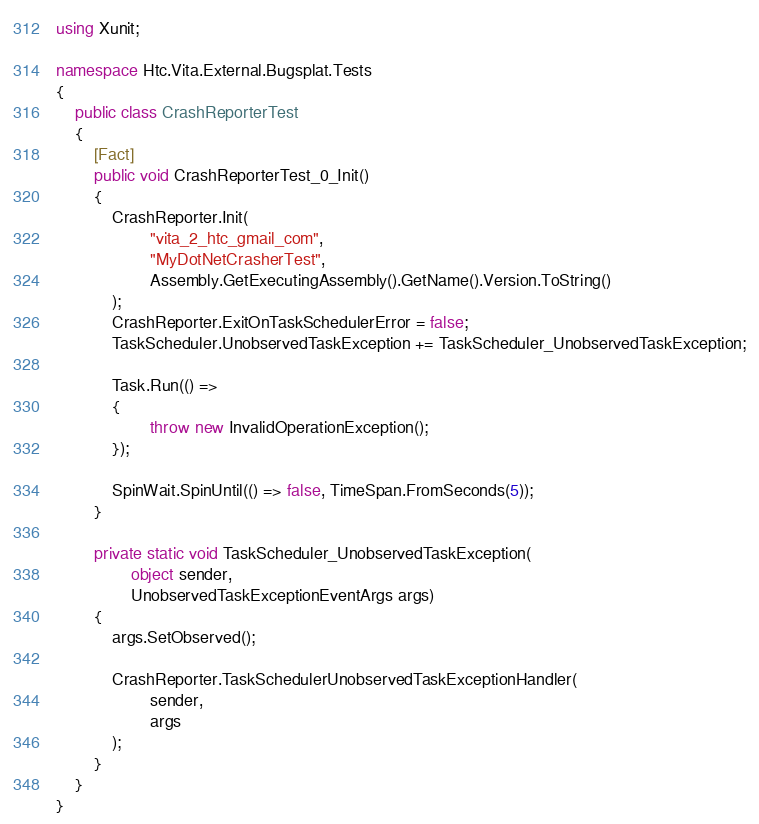<code> <loc_0><loc_0><loc_500><loc_500><_C#_>using Xunit;

namespace Htc.Vita.External.Bugsplat.Tests
{
    public class CrashReporterTest
    {
        [Fact]
        public void CrashReporterTest_0_Init()
        {
            CrashReporter.Init(
                    "vita_2_htc_gmail_com",
                    "MyDotNetCrasherTest",
                    Assembly.GetExecutingAssembly().GetName().Version.ToString()
            );
            CrashReporter.ExitOnTaskSchedulerError = false;
            TaskScheduler.UnobservedTaskException += TaskScheduler_UnobservedTaskException;

            Task.Run(() =>
            {
                    throw new InvalidOperationException();
            });

            SpinWait.SpinUntil(() => false, TimeSpan.FromSeconds(5));
        }

        private static void TaskScheduler_UnobservedTaskException(
                object sender,
                UnobservedTaskExceptionEventArgs args)
        {
            args.SetObserved();

            CrashReporter.TaskSchedulerUnobservedTaskExceptionHandler(
                    sender,
                    args
            );
        }
    }
}
</code> 